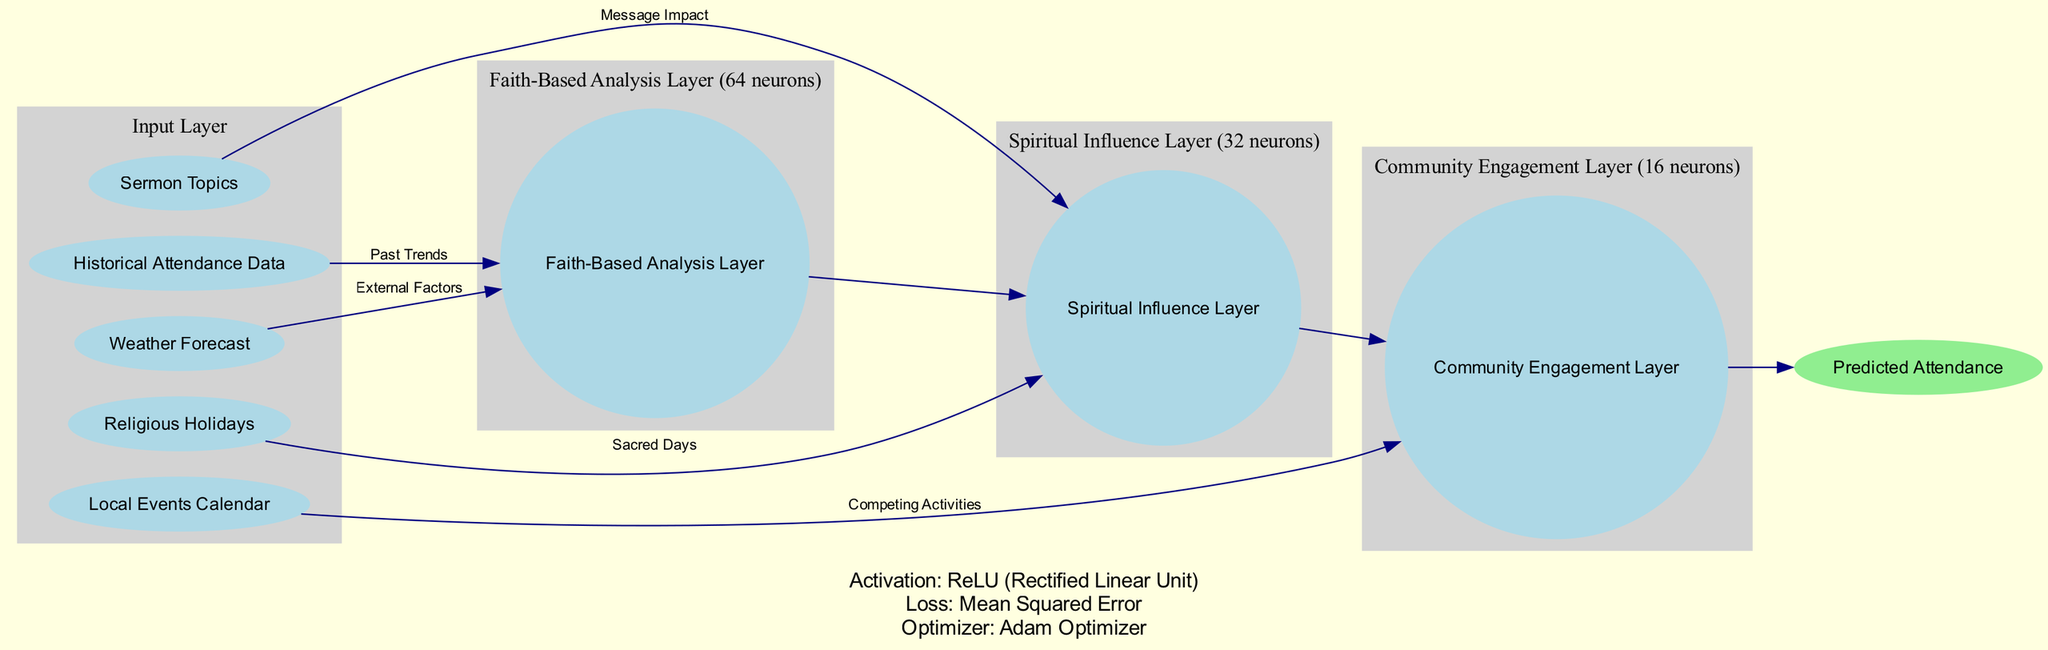What are the input nodes in this diagram? The input nodes are explicitly listed in the data section as sources for the neural network input layer. They include "Historical Attendance Data," "Weather Forecast," "Religious Holidays," "Local Events Calendar," and "Sermon Topics."
Answer: Historical Attendance Data, Weather Forecast, Religious Holidays, Local Events Calendar, Sermon Topics How many neurons are in the Faith-Based Analysis Layer? The number of neurons is given in the hidden layers' data section where it states that the "Faith-Based Analysis Layer" consists of 64 neurons.
Answer: 64 What is the output node of this neural network? The output node is clearly specified in the diagram data, indicating that the final result predicted by the network is "Predicted Attendance."
Answer: Predicted Attendance Which layer analyzes the impact of Sermon Topics? The flow of connections indicates that "Sermon Topics" is directed to the "Spiritual Influence Layer," thus it is the layer analyzing sermon impact.
Answer: Spiritual Influence Layer What is the activation function used in this neural network? The activation function is stated directly in the data section, which specifies it as the "ReLU (Rectified Linear Unit)."
Answer: ReLU (Rectified Linear Unit) How many hidden layers are present in this diagram? By counting the entries in the hidden layers section, we find three layers: "Faith-Based Analysis Layer," "Spiritual Influence Layer," and "Community Engagement Layer."
Answer: 3 What type of connection exists between the Historical Attendance Data and the Faith-Based Analysis Layer? The diagram explicitly indicates that there is a connection labeled "Past Trends" from "Historical Attendance Data" to "Faith-Based Analysis Layer."
Answer: Past Trends What is the role of the Community Engagement Layer in this network? The "Community Engagement Layer" is connected to "Local Events Calendar," suggesting it assesses external activities competing for attendance, indicating its role in analyzing community factors.
Answer: Analyzing community factors Which optimizer is used for this neural network? The choice of optimizer is mentioned directly in the diagram data under the parameters section, specifying that the "Adam Optimizer" is used for training the network.
Answer: Adam Optimizer 